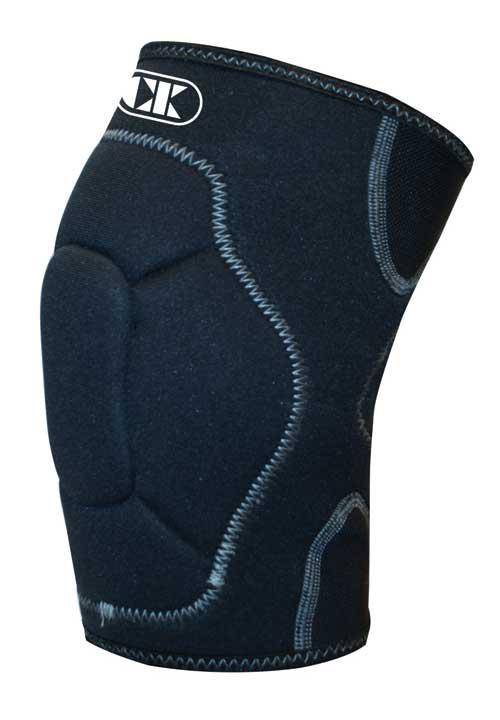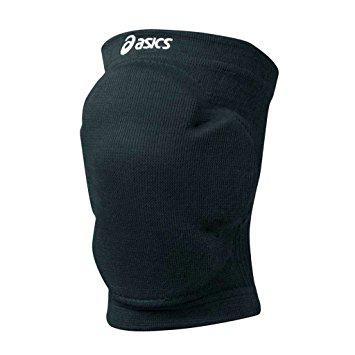The first image is the image on the left, the second image is the image on the right. Assess this claim about the two images: "A total of two knee pads without a knee opening are shown.". Correct or not? Answer yes or no. Yes. 